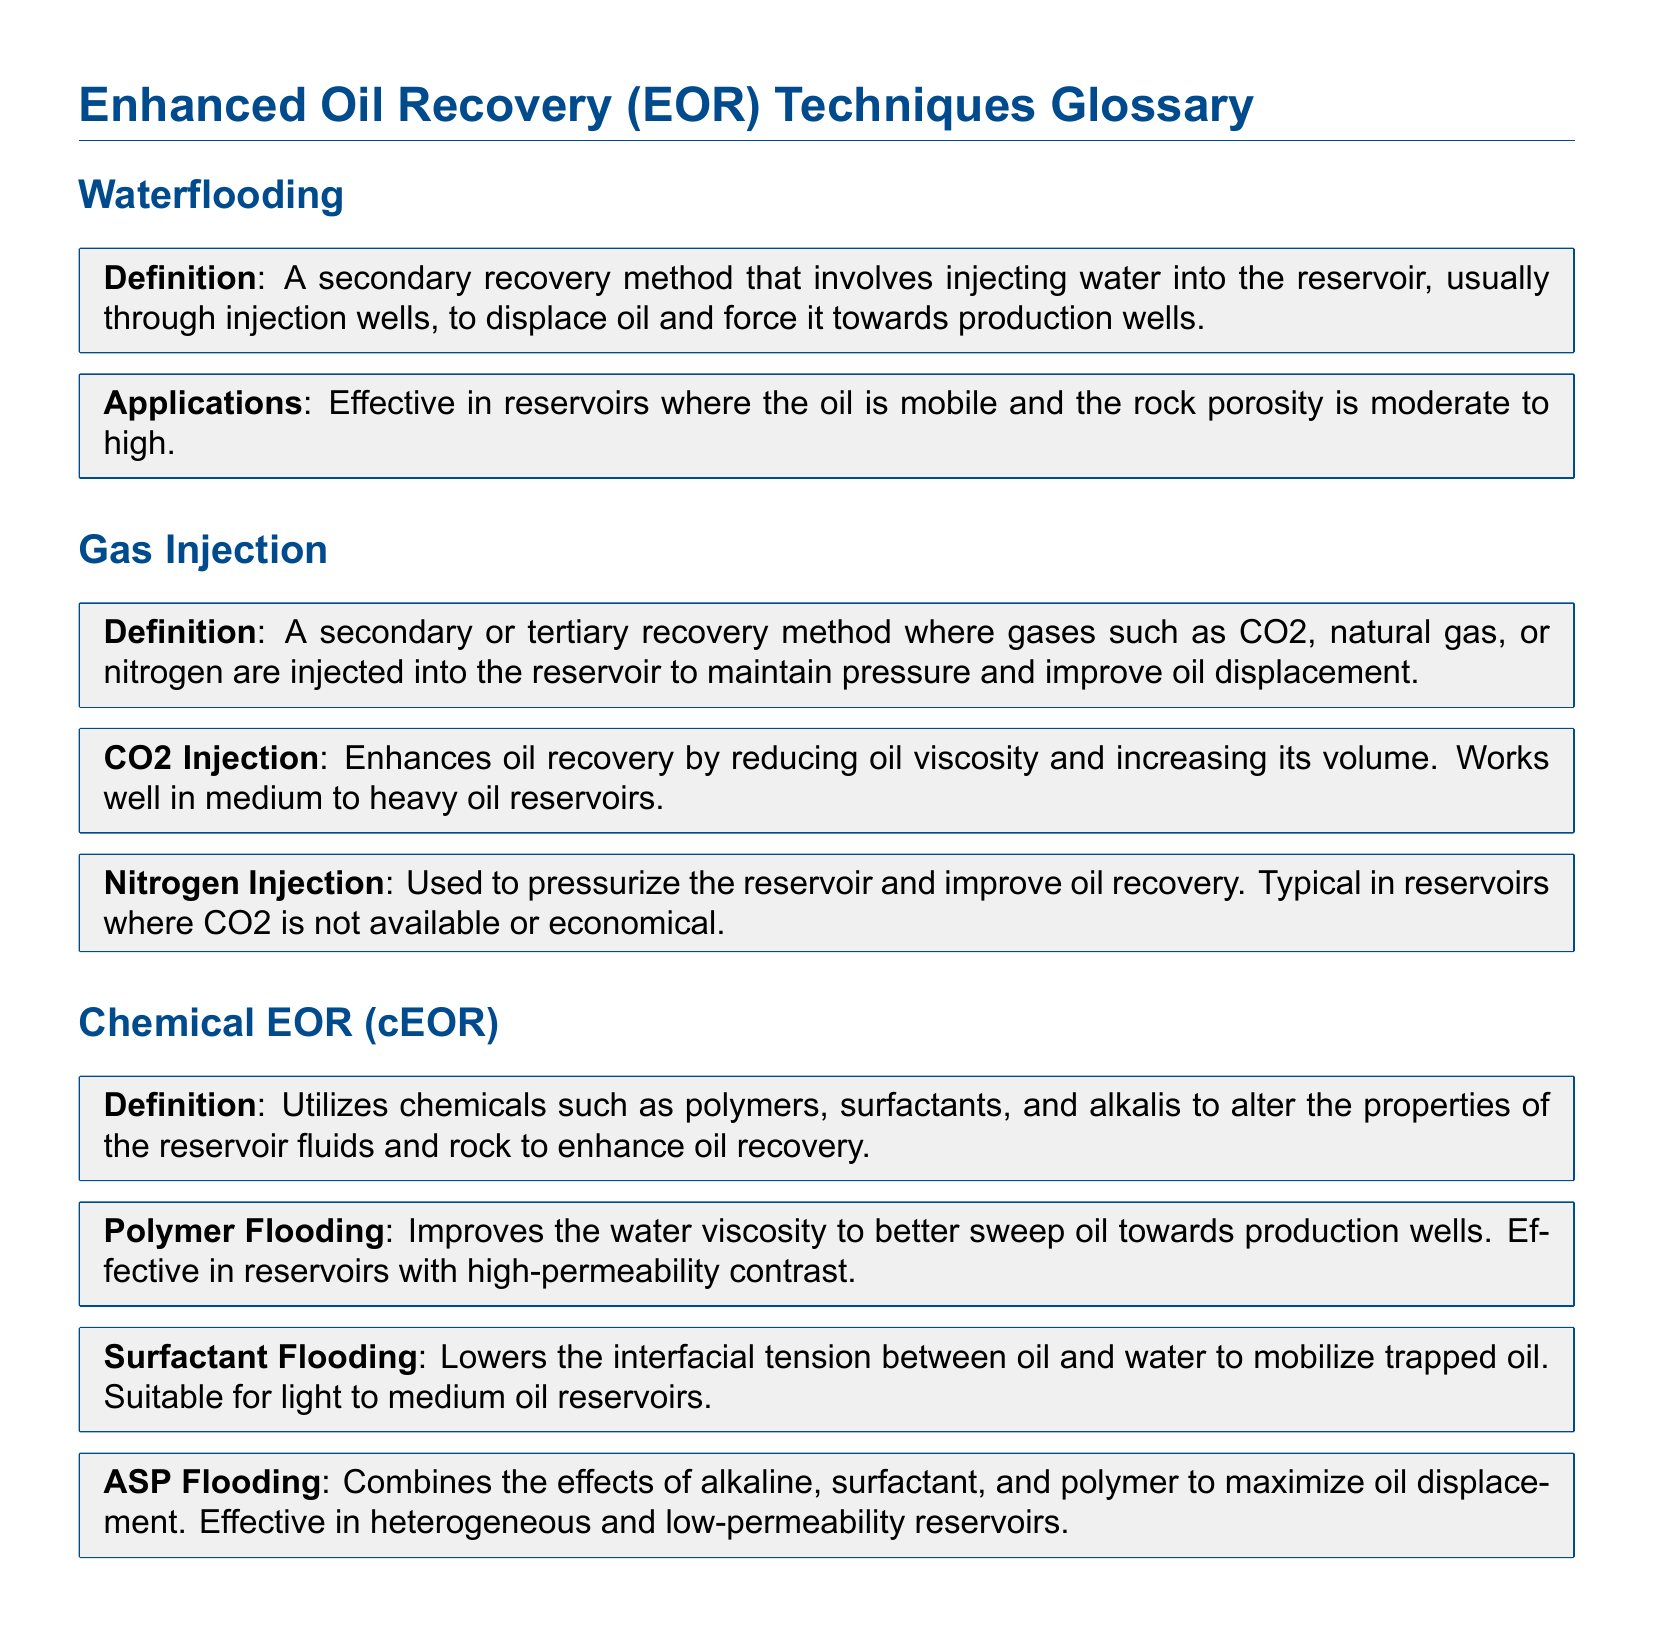What is waterflooding? Waterflooding is defined as a secondary recovery method involving injecting water into the reservoir.
Answer: A secondary recovery method What does gas injection improve? Gas injection improves oil displacement and maintains pressure in the reservoir.
Answer: Oil displacement What chemicals are used in Chemical EOR? Chemical EOR utilizes chemicals such as polymers, surfactants, and alkalis.
Answer: Polymers, surfactants, and alkalis Which gas is used in CO2 injection? CO2 injection uses carbon dioxide as the gas for injection.
Answer: Carbon dioxide What type of reservoirs is polymer flooding effective in? Polymer flooding is effective in reservoirs with high-permeability contrast.
Answer: High-permeability contrast What does surfactant flooding lower? Surfactant flooding lowers the interfacial tension between oil and water.
Answer: Interfacial tension How many main types of gas injections are mentioned? The document mentions two types of gas injections: CO2 injection and nitrogen injection.
Answer: Two What is the primary goal of the ASP flooding method? The primary goal of ASP flooding is to maximize oil displacement.
Answer: Maximize oil displacement What is the typical rock porosity for waterflooding applications? Waterflooding is effective in reservoirs with moderate to high rock porosity.
Answer: Moderate to high 